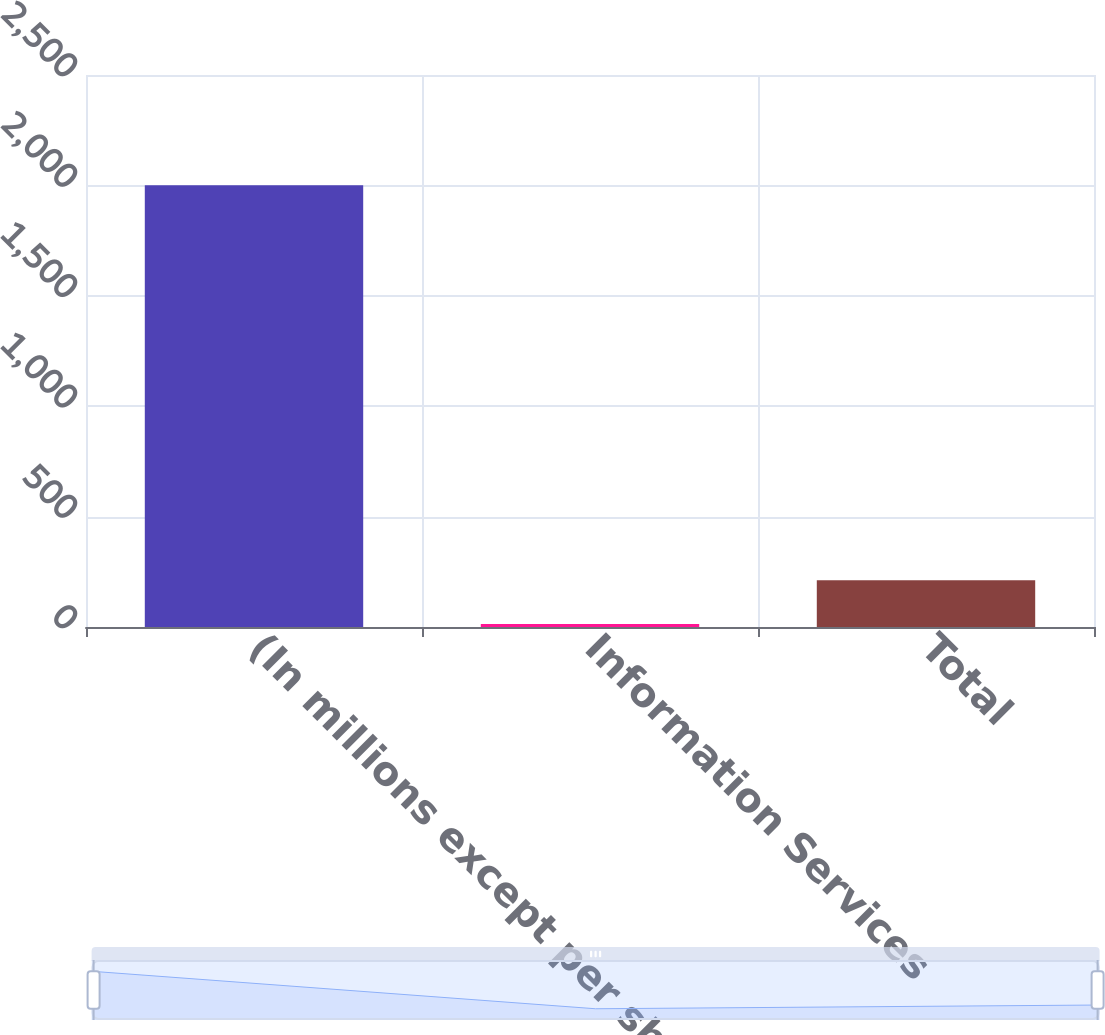Convert chart to OTSL. <chart><loc_0><loc_0><loc_500><loc_500><bar_chart><fcel>(In millions except per share<fcel>Information Services<fcel>Total<nl><fcel>2001<fcel>13.2<fcel>211.98<nl></chart> 